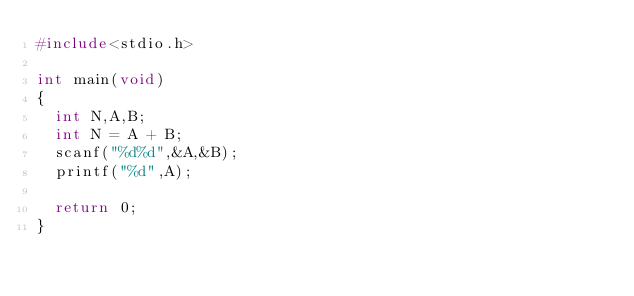<code> <loc_0><loc_0><loc_500><loc_500><_C_>#include<stdio.h>

int main(void)
{
  int N,A,B;
  int N = A + B;
  scanf("%d%d",&A,&B);
  printf("%d",A);
  
  return 0;
}</code> 